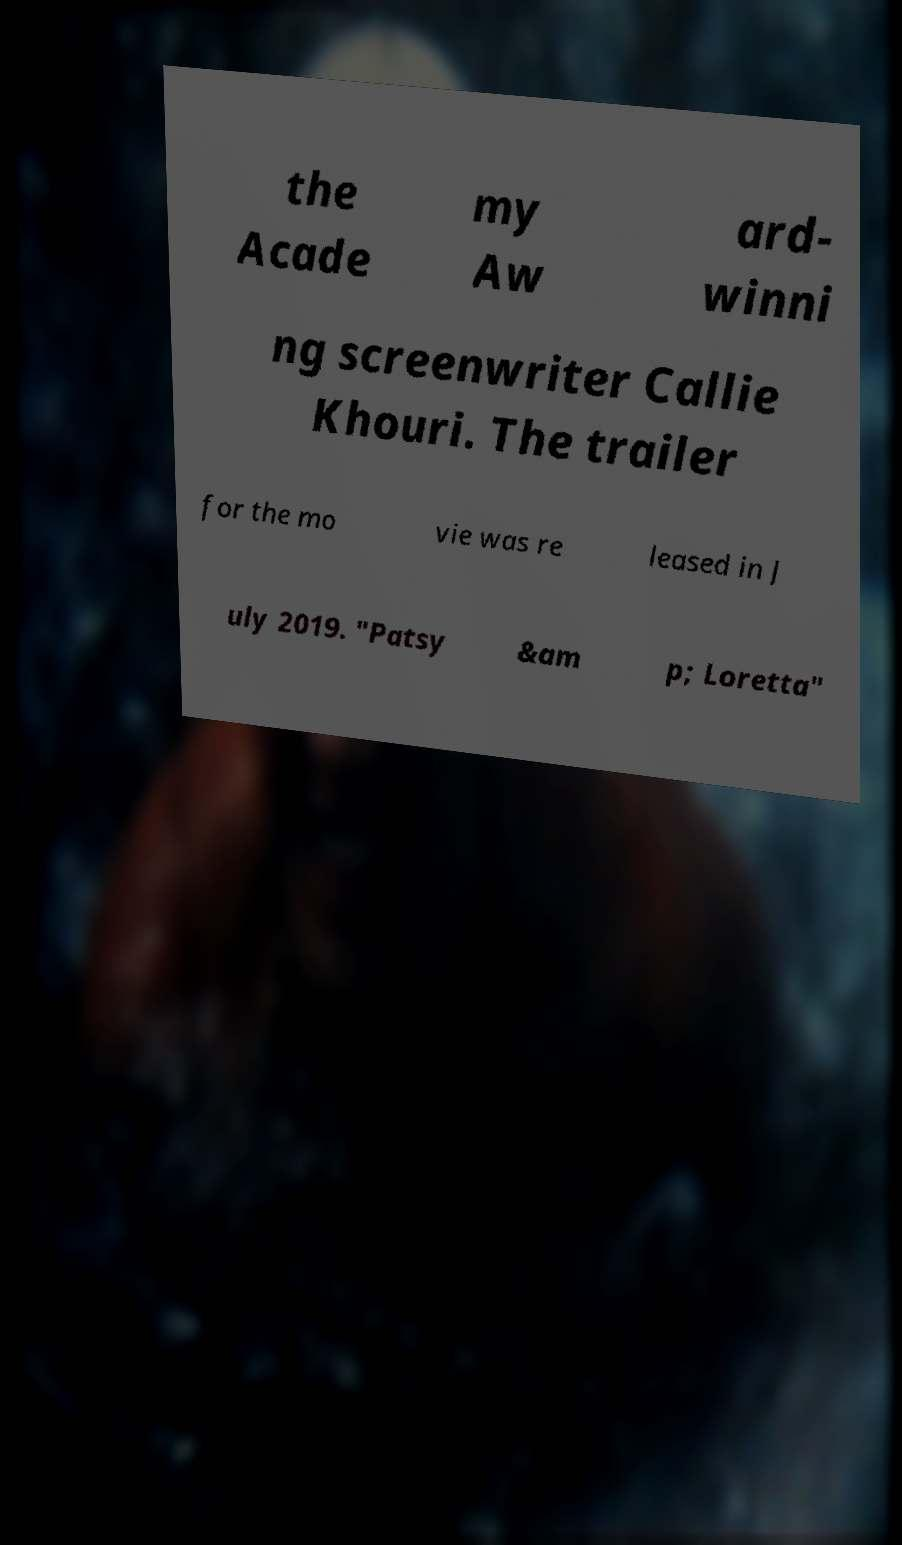There's text embedded in this image that I need extracted. Can you transcribe it verbatim? the Acade my Aw ard- winni ng screenwriter Callie Khouri. The trailer for the mo vie was re leased in J uly 2019. "Patsy &am p; Loretta" 